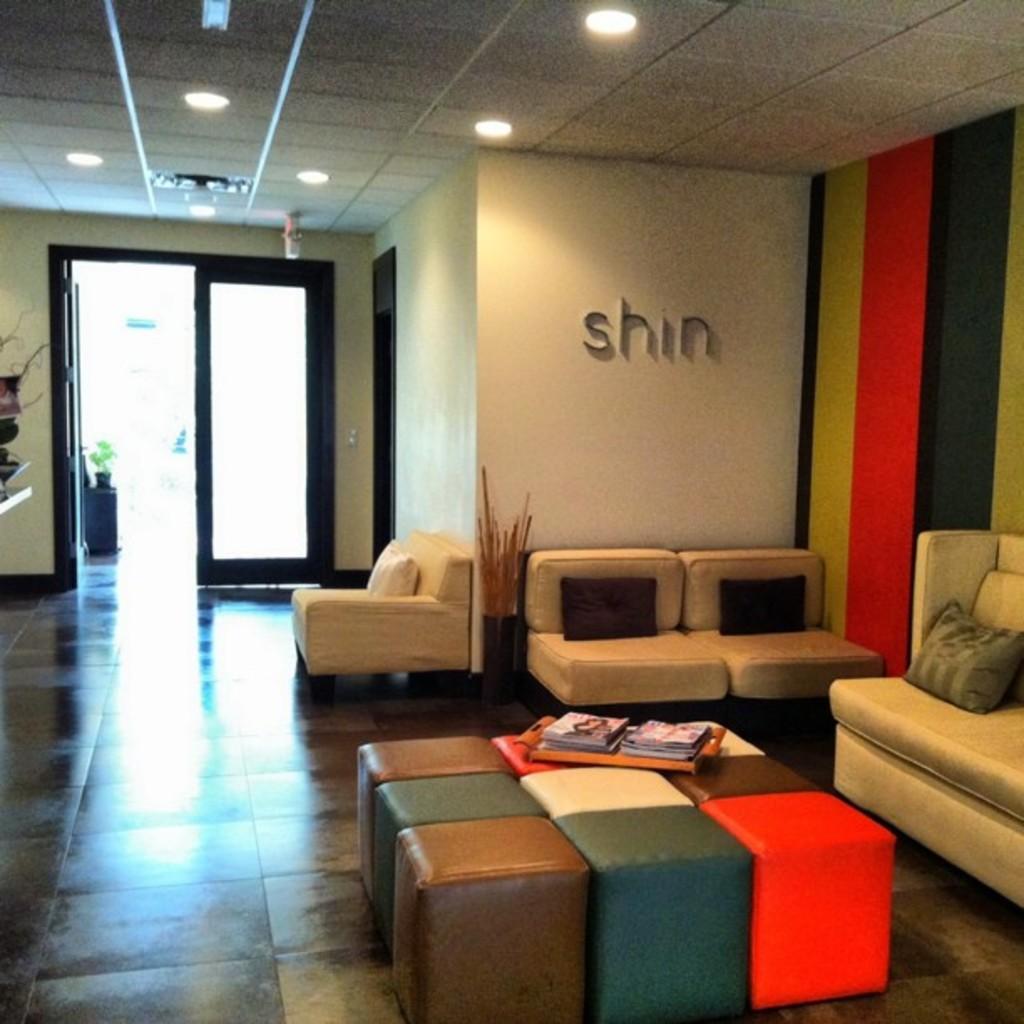Please provide a concise description of this image. In this picture we can see a room with sofas pillows on outdoor, wall, stools, tray with books in it, floor, lights. 